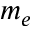<formula> <loc_0><loc_0><loc_500><loc_500>m _ { e }</formula> 